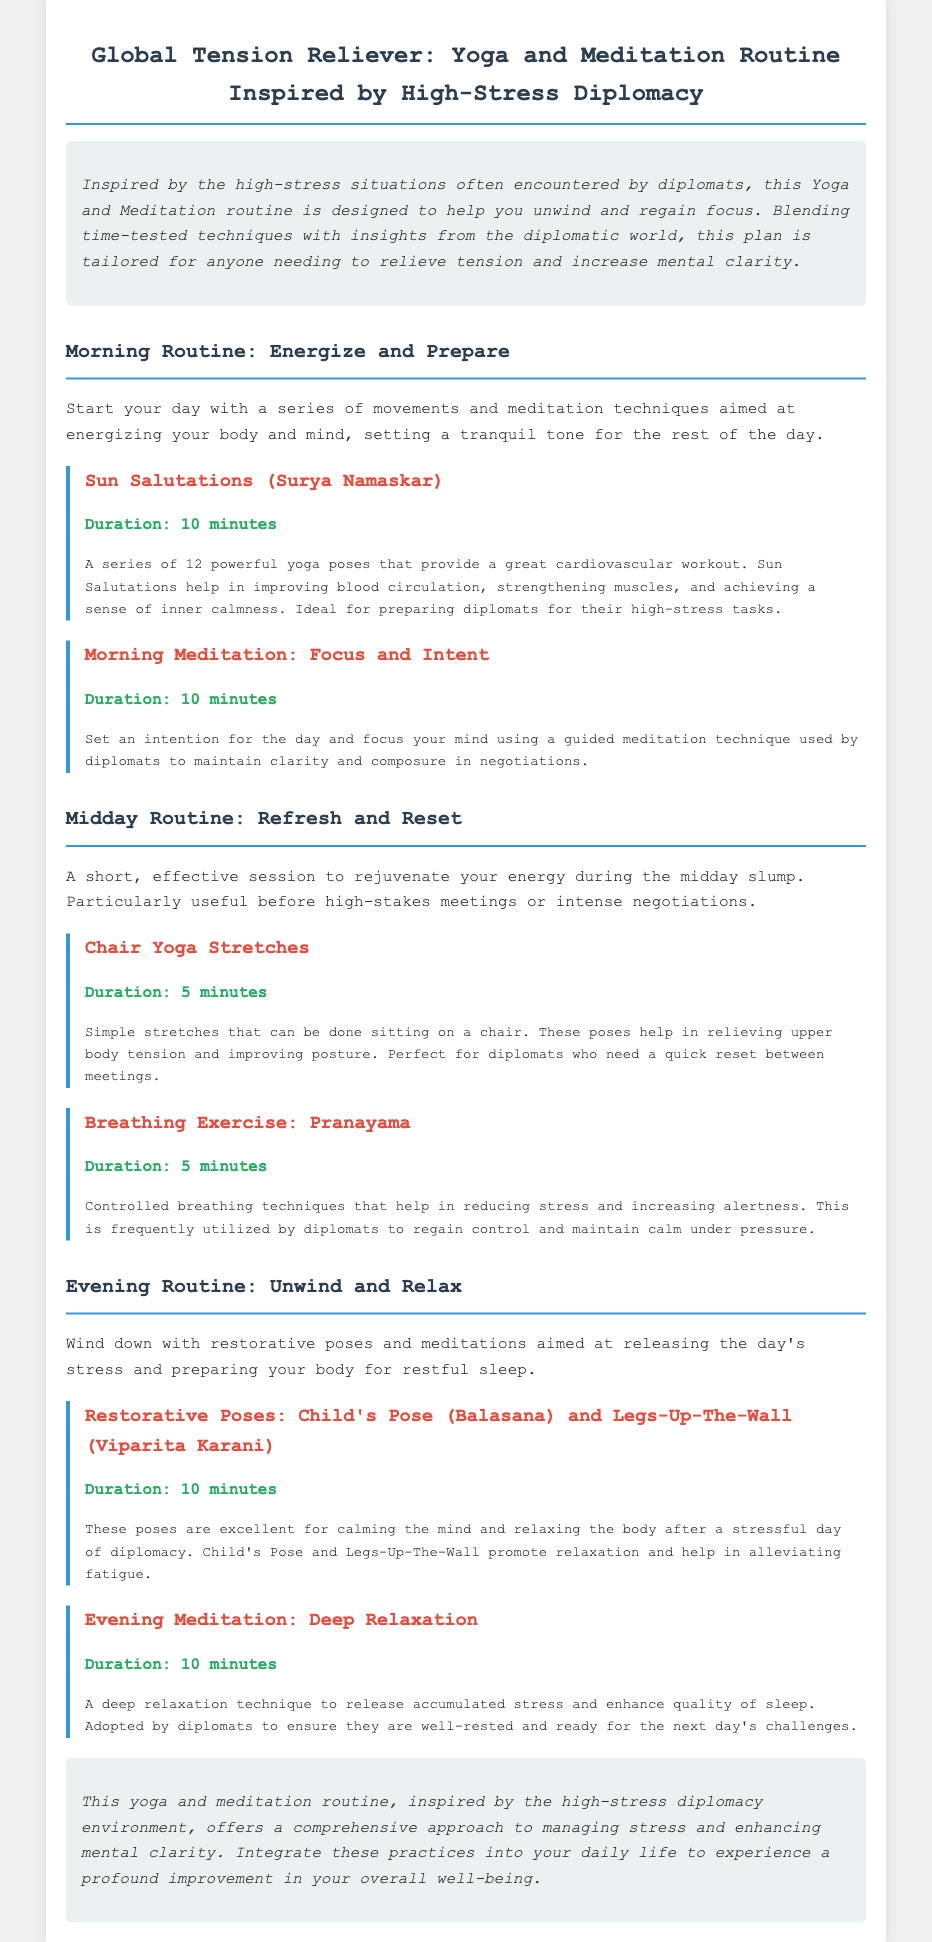What is the title of the document? The title of the document is given in the header as "Global Tension Reliever: Yoga and Meditation Routine Inspired by High-Stress Diplomacy."
Answer: Global Tension Reliever: Yoga and Meditation Routine Inspired by High-Stress Diplomacy How long should the Morning Meditation last? The duration of the Morning Meditation is specified in the document as 10 minutes.
Answer: 10 minutes What is the first activity listed in the Morning Routine? The first activity mentioned in the Morning Routine is “Sun Salutations (Surya Namaskar).”
Answer: Sun Salutations (Surya Namaskar) What is the purpose of Chair Yoga Stretches? The document explains that Chair Yoga Stretches help in relieving upper body tension and improving posture.
Answer: Relieving upper body tension and improving posture How long is the total duration of the Evening Routine? The total duration of the Evening Routine can be calculated by adding the durations of its activities, which are both 10 minutes each; therefore, it is 20 minutes.
Answer: 20 minutes 